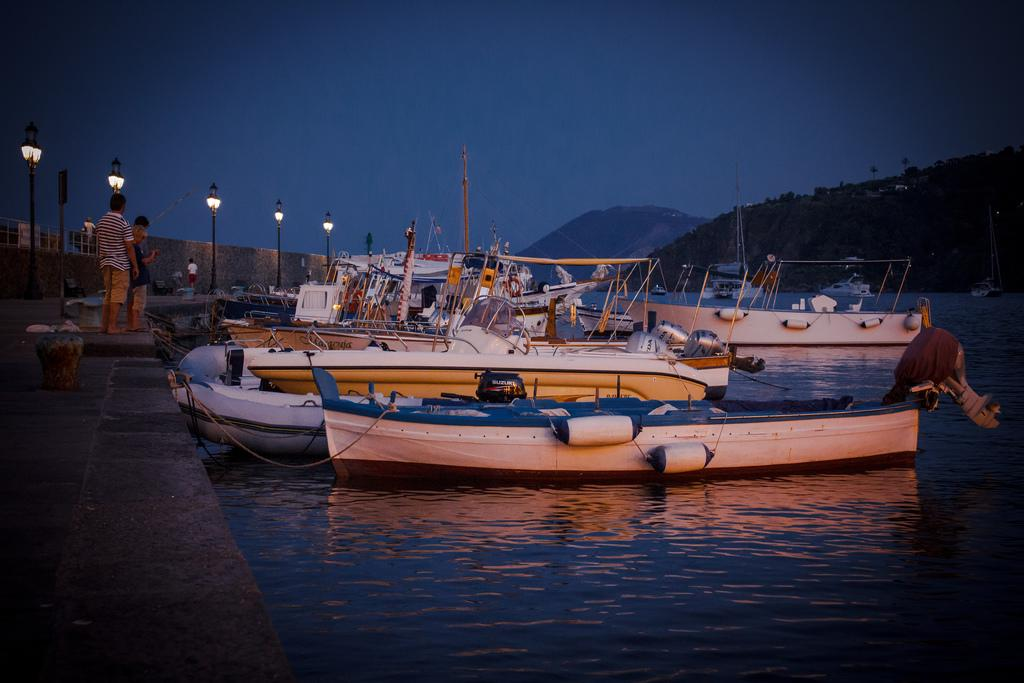What is the main subject in the center of the image? There are boats in the center of the image. What body of water are the boats in? There is a river at the bottom of the image. What can be seen on the left side of the image? There are people standing on the left side of the image. What structures are present in the image? There are poles in the image. What can be seen in the background of the image? There are hills and the sky visible in the background of the image. What type of toe is being taught by the person in the image? There is no person teaching a toe in the image; the image features boats, a river, people, poles, hills, and the sky. 